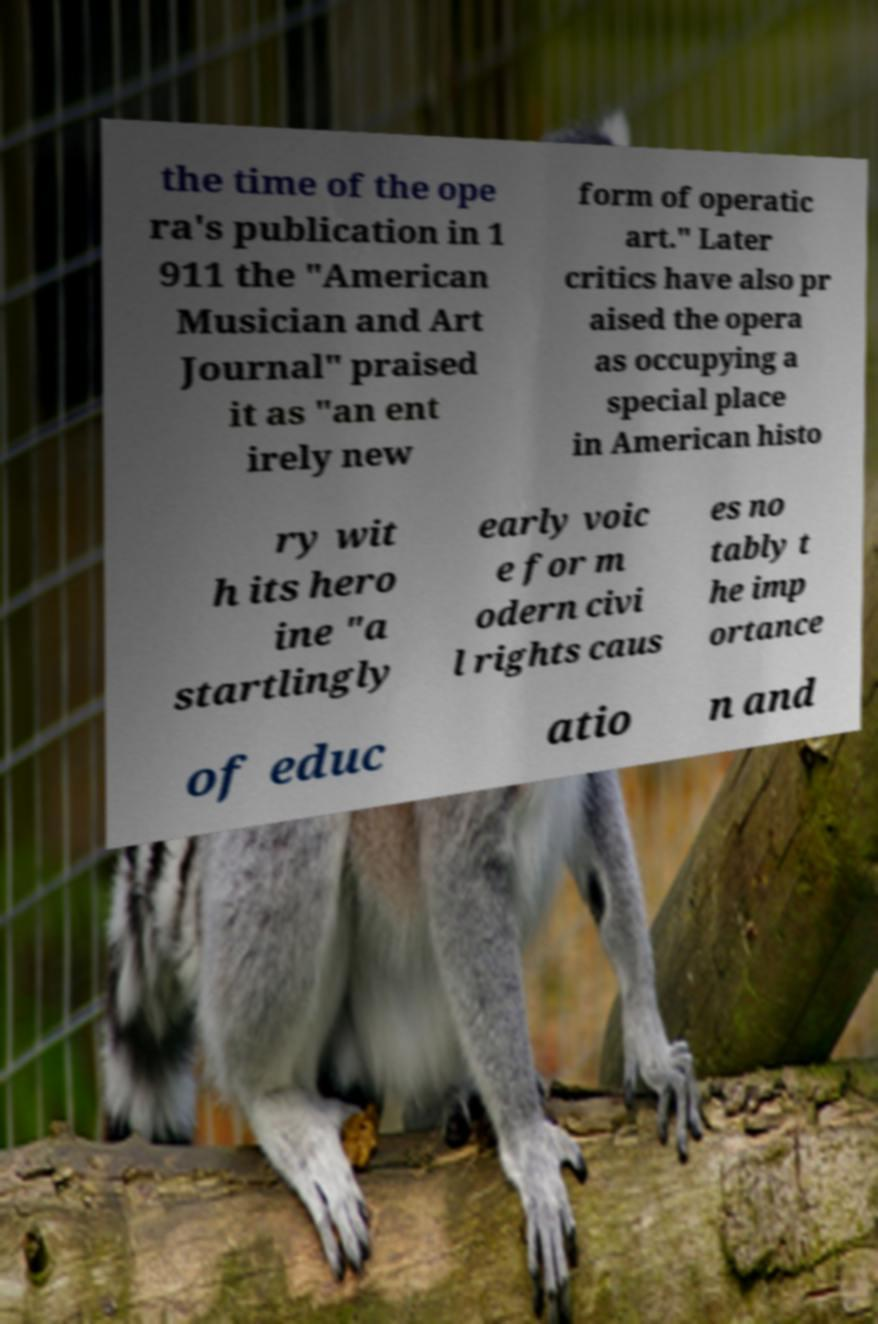Could you extract and type out the text from this image? the time of the ope ra's publication in 1 911 the "American Musician and Art Journal" praised it as "an ent irely new form of operatic art." Later critics have also pr aised the opera as occupying a special place in American histo ry wit h its hero ine "a startlingly early voic e for m odern civi l rights caus es no tably t he imp ortance of educ atio n and 